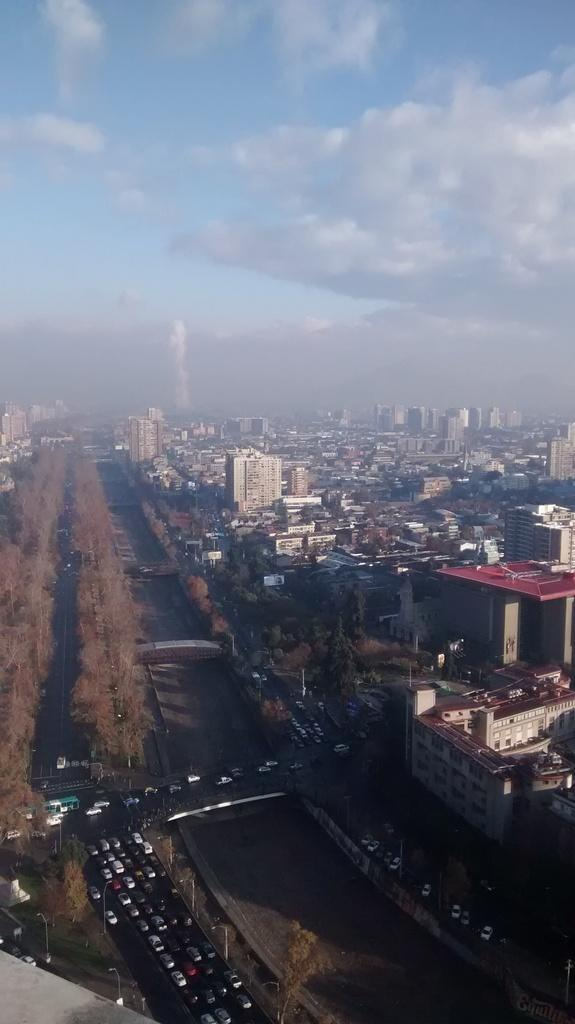What type of view is provided in the image? The image is a top view of a place. What types of structures can be seen in the image? There are buildings and houses in the image. What type of transportation is visible in the image? There are cars in the image. What type of natural elements are present in the image? There are trees in the image. Can you describe any other unspecified things in the image? There are other unspecified things in the image, but we cannot provide more details without additional information. What advice is the laborer giving to the authority in the image? There is no laborer or authority present in the image, so no such interaction can be observed. 